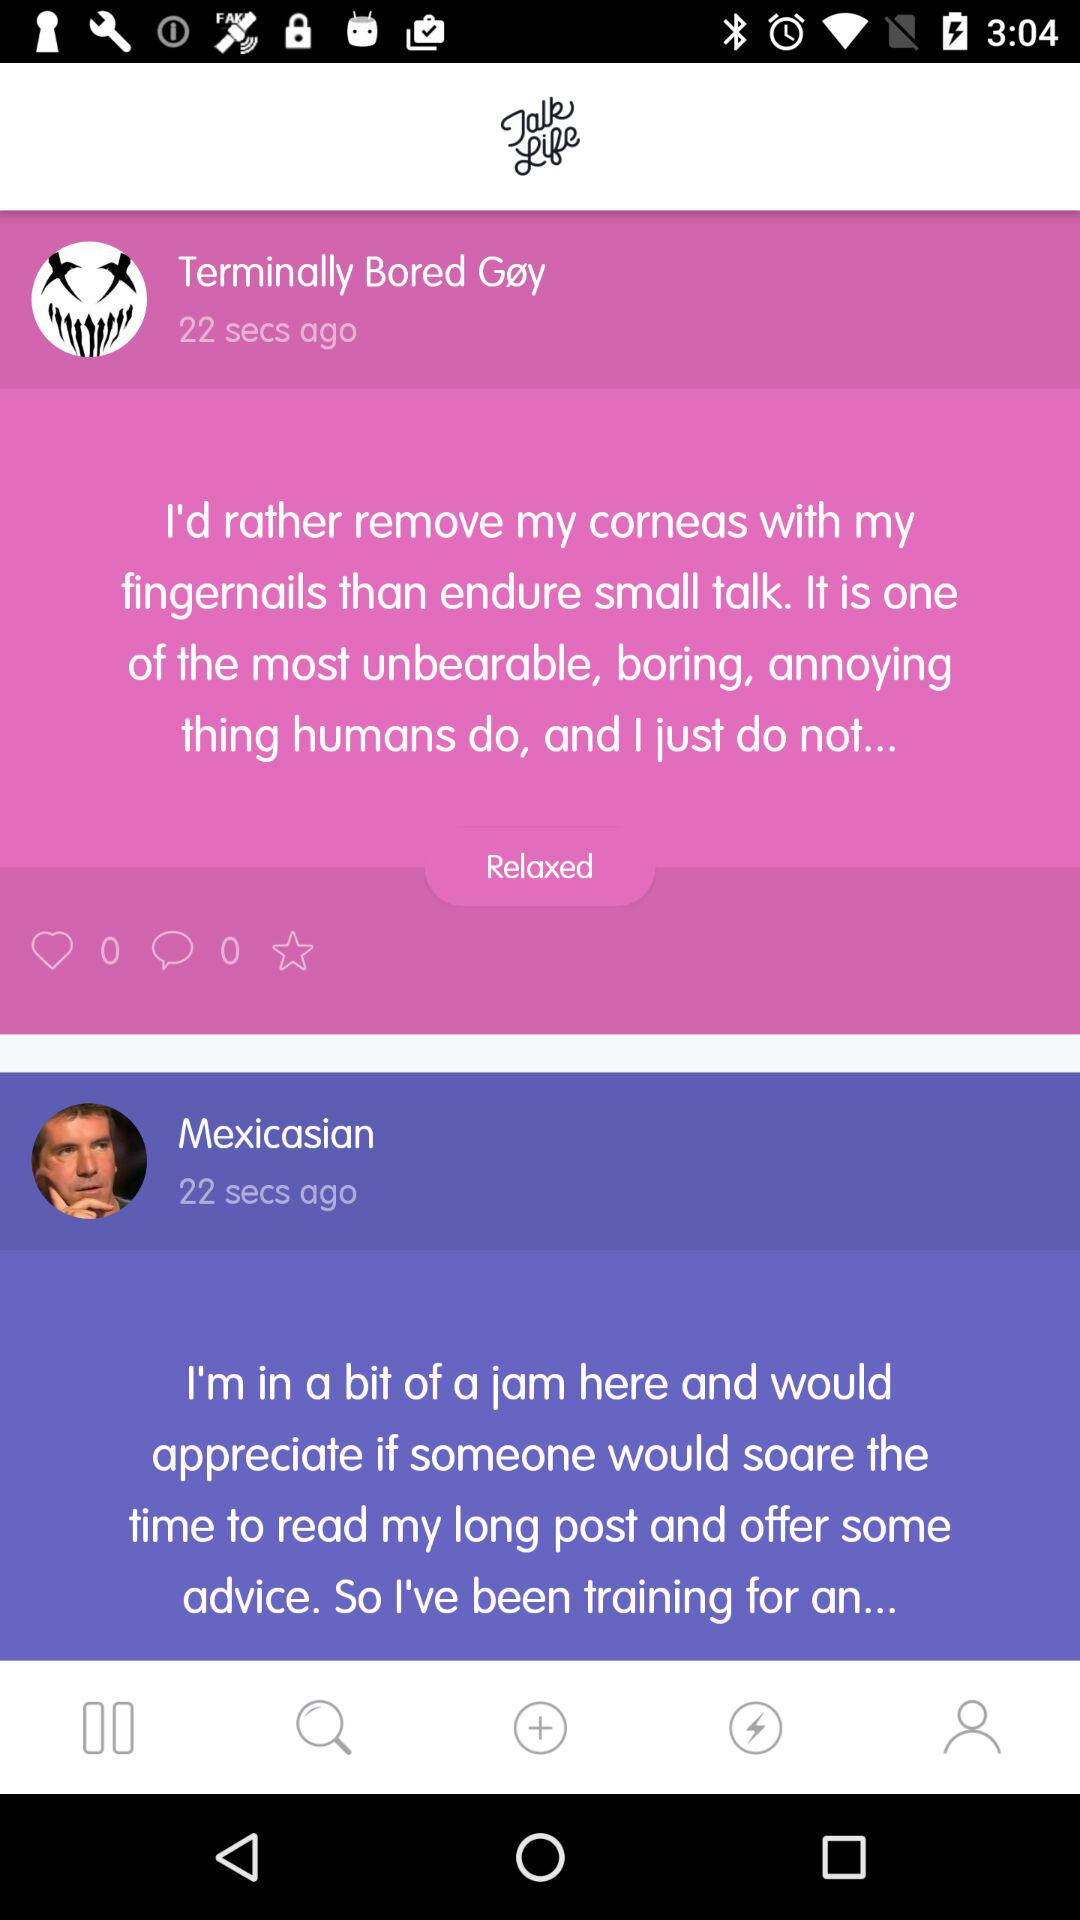What was the count of comments? The count of comments was 0. 